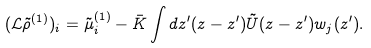<formula> <loc_0><loc_0><loc_500><loc_500>( \mathcal { L } \tilde { \rho } ^ { ( 1 ) } ) _ { i } = \tilde { \mu } _ { i } ^ { ( 1 ) } - { \bar { K } } \int d z ^ { \prime } ( z - z ^ { \prime } ) \tilde { U } ( z - z ^ { \prime } ) w _ { j } ( z ^ { \prime } ) .</formula> 